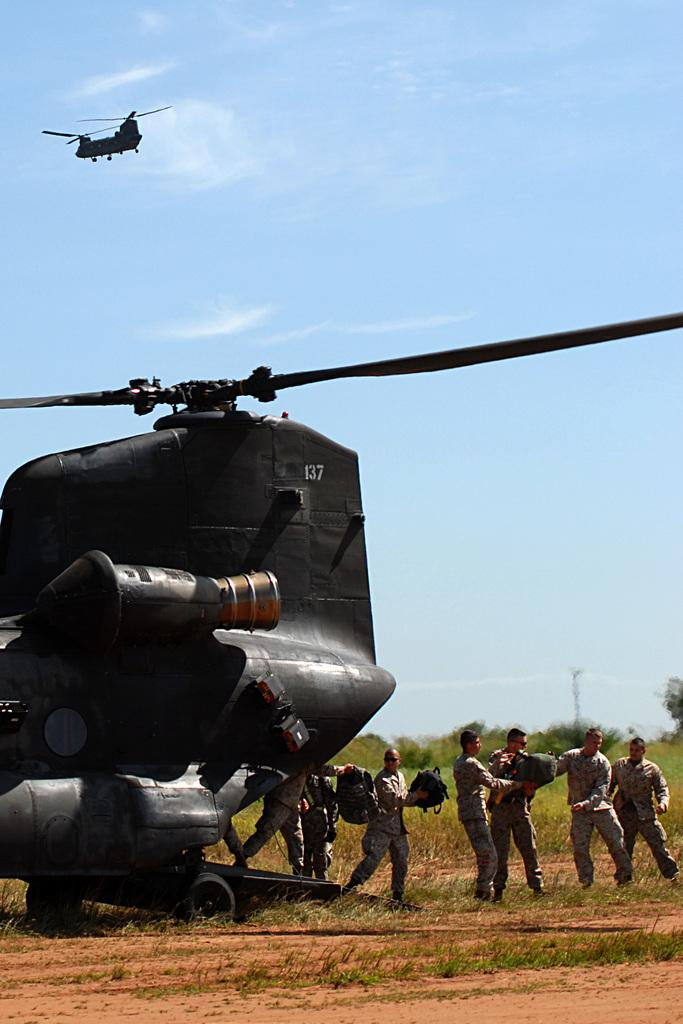What type of aircraft is shown in the image? There are chinook boeings in the image. What are the people in the image doing? The people are standing in the image and holding bags in their hands. What type of vegetation can be seen in the image? There are trees visible in the image. What is the ground covered with in the image? There is grass on the ground in the image. How would you describe the sky in the image? The sky is blue and cloudy in the image. Can you see a rabbit hopping on the sidewalk in the image? There is no rabbit or sidewalk present in the image. What type of sand can be seen near the grass in the image? There is no sand visible in the image; it features grass on the ground. 